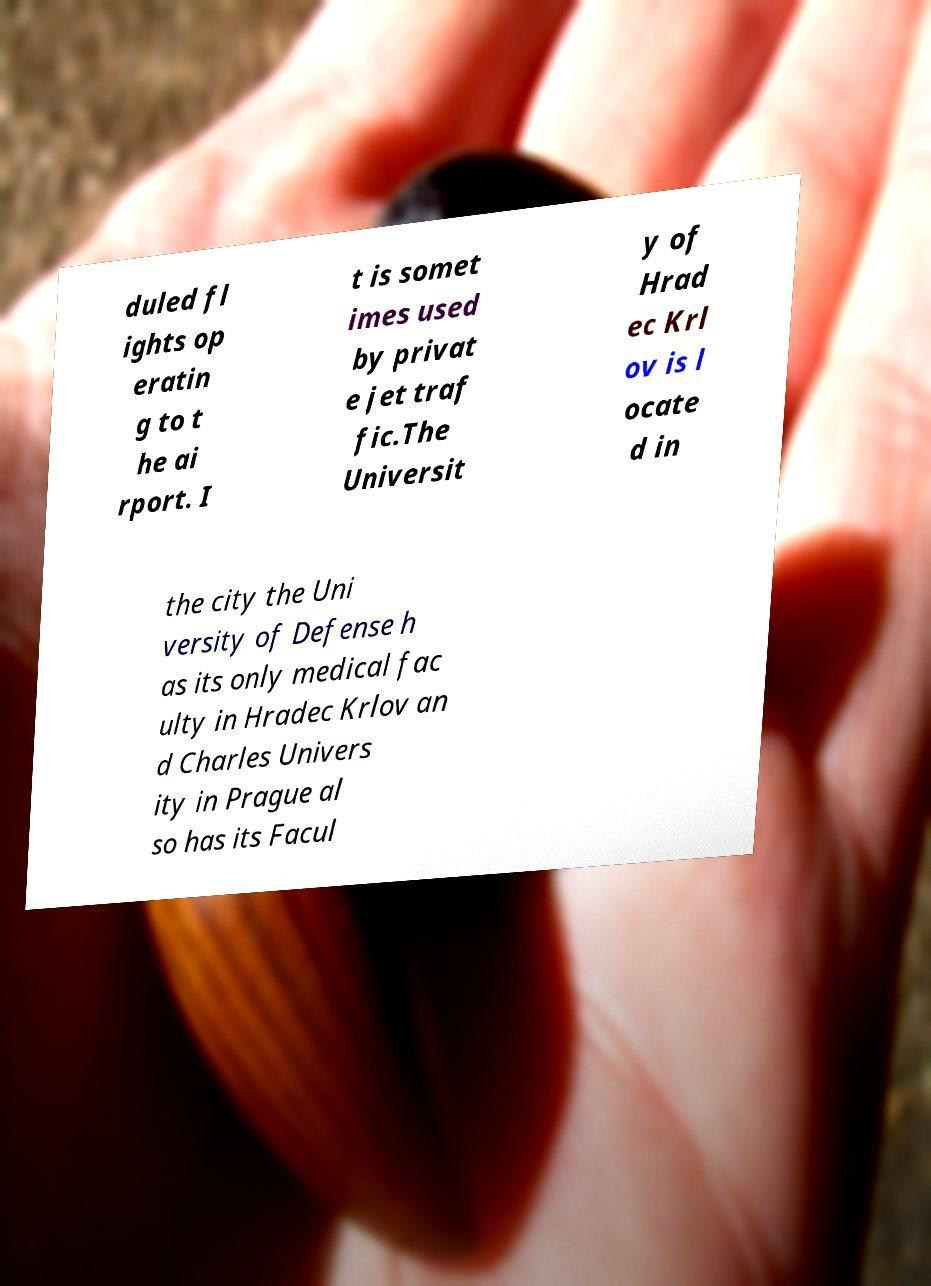For documentation purposes, I need the text within this image transcribed. Could you provide that? duled fl ights op eratin g to t he ai rport. I t is somet imes used by privat e jet traf fic.The Universit y of Hrad ec Krl ov is l ocate d in the city the Uni versity of Defense h as its only medical fac ulty in Hradec Krlov an d Charles Univers ity in Prague al so has its Facul 